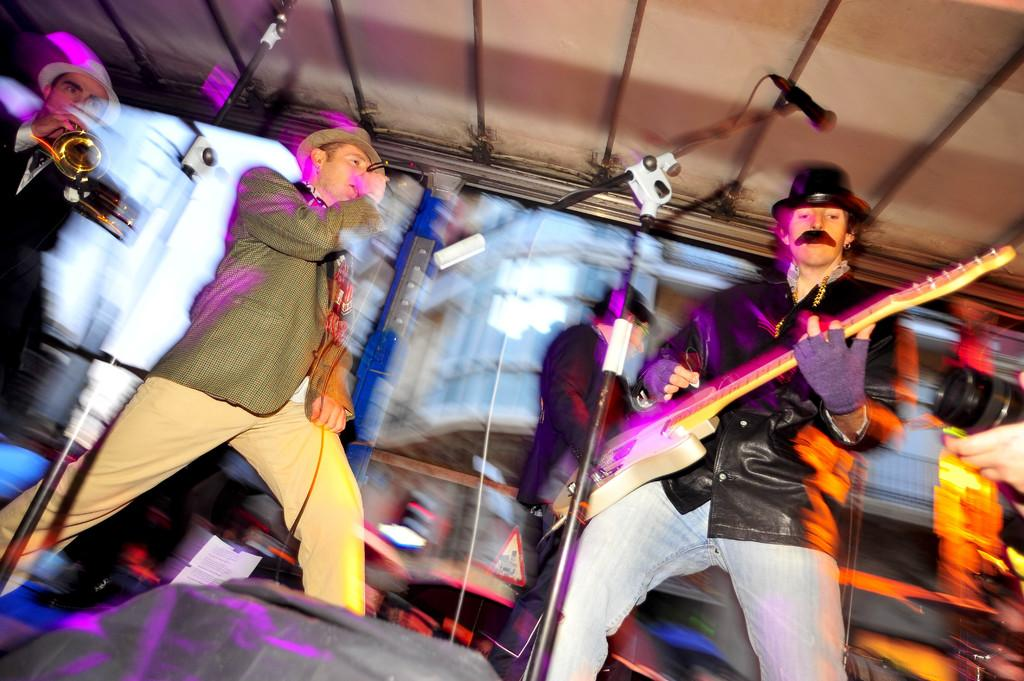What are the people in the image doing? Some people are holding musical instruments. What object is visible that is commonly used for amplifying sound? There is a microphone (mic) visible in the image. What type of spring can be seen in the image? There is no spring present in the image. How does the weather affect the performance in the image? The provided facts do not mention any weather conditions, so it is impossible to determine how the weather might affect the performance. 